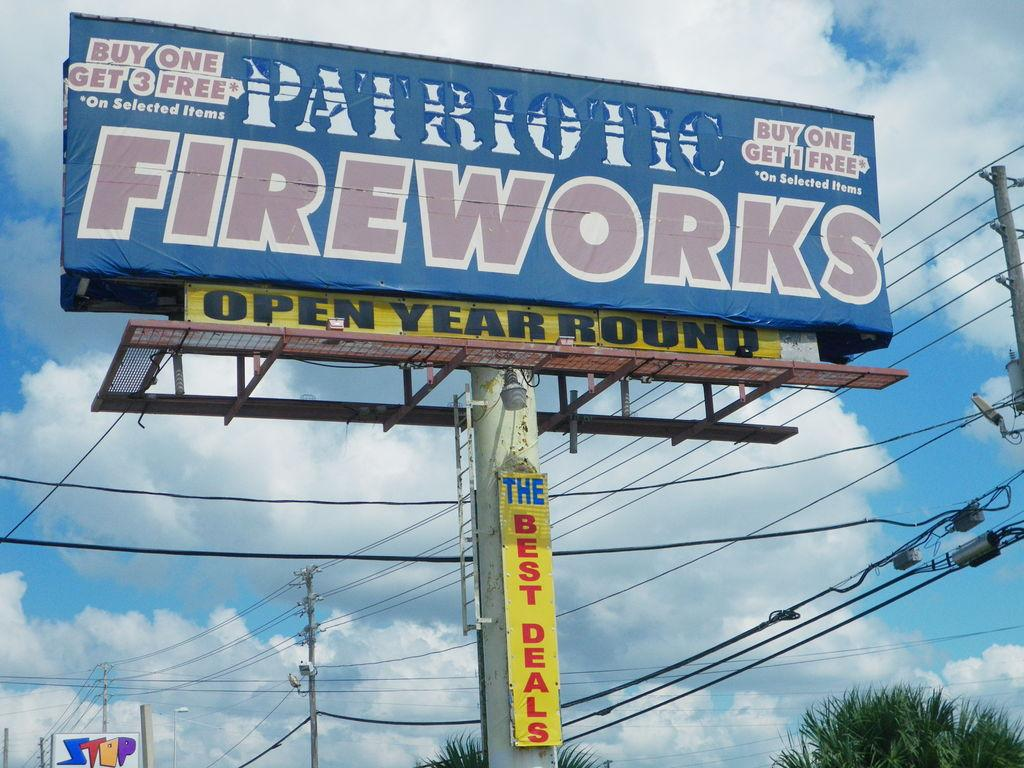Provide a one-sentence caption for the provided image. Big sign outside with Patriotic Fireworks wrote on it. 